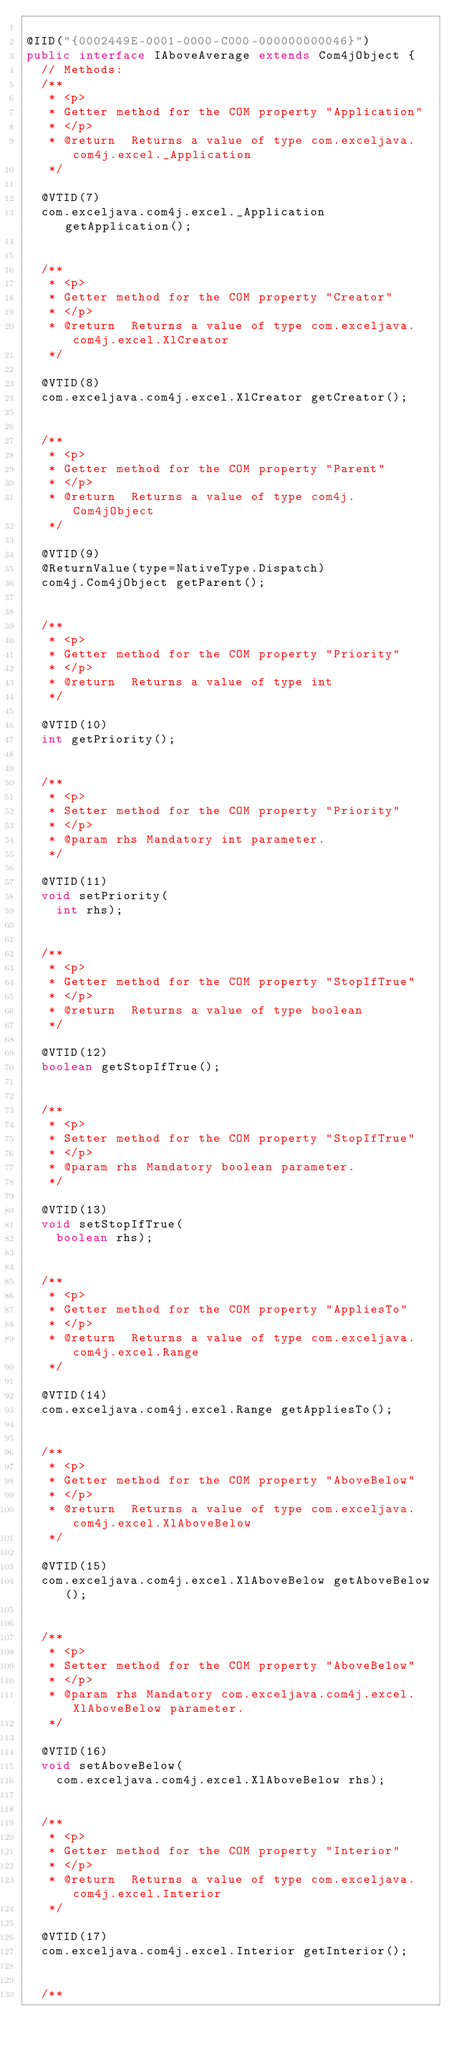Convert code to text. <code><loc_0><loc_0><loc_500><loc_500><_Java_>
@IID("{0002449E-0001-0000-C000-000000000046}")
public interface IAboveAverage extends Com4jObject {
  // Methods:
  /**
   * <p>
   * Getter method for the COM property "Application"
   * </p>
   * @return  Returns a value of type com.exceljava.com4j.excel._Application
   */

  @VTID(7)
  com.exceljava.com4j.excel._Application getApplication();


  /**
   * <p>
   * Getter method for the COM property "Creator"
   * </p>
   * @return  Returns a value of type com.exceljava.com4j.excel.XlCreator
   */

  @VTID(8)
  com.exceljava.com4j.excel.XlCreator getCreator();


  /**
   * <p>
   * Getter method for the COM property "Parent"
   * </p>
   * @return  Returns a value of type com4j.Com4jObject
   */

  @VTID(9)
  @ReturnValue(type=NativeType.Dispatch)
  com4j.Com4jObject getParent();


  /**
   * <p>
   * Getter method for the COM property "Priority"
   * </p>
   * @return  Returns a value of type int
   */

  @VTID(10)
  int getPriority();


  /**
   * <p>
   * Setter method for the COM property "Priority"
   * </p>
   * @param rhs Mandatory int parameter.
   */

  @VTID(11)
  void setPriority(
    int rhs);


  /**
   * <p>
   * Getter method for the COM property "StopIfTrue"
   * </p>
   * @return  Returns a value of type boolean
   */

  @VTID(12)
  boolean getStopIfTrue();


  /**
   * <p>
   * Setter method for the COM property "StopIfTrue"
   * </p>
   * @param rhs Mandatory boolean parameter.
   */

  @VTID(13)
  void setStopIfTrue(
    boolean rhs);


  /**
   * <p>
   * Getter method for the COM property "AppliesTo"
   * </p>
   * @return  Returns a value of type com.exceljava.com4j.excel.Range
   */

  @VTID(14)
  com.exceljava.com4j.excel.Range getAppliesTo();


  /**
   * <p>
   * Getter method for the COM property "AboveBelow"
   * </p>
   * @return  Returns a value of type com.exceljava.com4j.excel.XlAboveBelow
   */

  @VTID(15)
  com.exceljava.com4j.excel.XlAboveBelow getAboveBelow();


  /**
   * <p>
   * Setter method for the COM property "AboveBelow"
   * </p>
   * @param rhs Mandatory com.exceljava.com4j.excel.XlAboveBelow parameter.
   */

  @VTID(16)
  void setAboveBelow(
    com.exceljava.com4j.excel.XlAboveBelow rhs);


  /**
   * <p>
   * Getter method for the COM property "Interior"
   * </p>
   * @return  Returns a value of type com.exceljava.com4j.excel.Interior
   */

  @VTID(17)
  com.exceljava.com4j.excel.Interior getInterior();


  /**</code> 